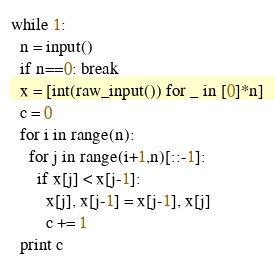<code> <loc_0><loc_0><loc_500><loc_500><_Python_>while 1:
  n = input()
  if n==0: break
  x = [int(raw_input()) for _ in [0]*n]
  c = 0
  for i in range(n):
    for j in range(i+1,n)[::-1]:
      if x[j] < x[j-1]:
        x[j], x[j-1] = x[j-1], x[j]
        c += 1
  print c</code> 